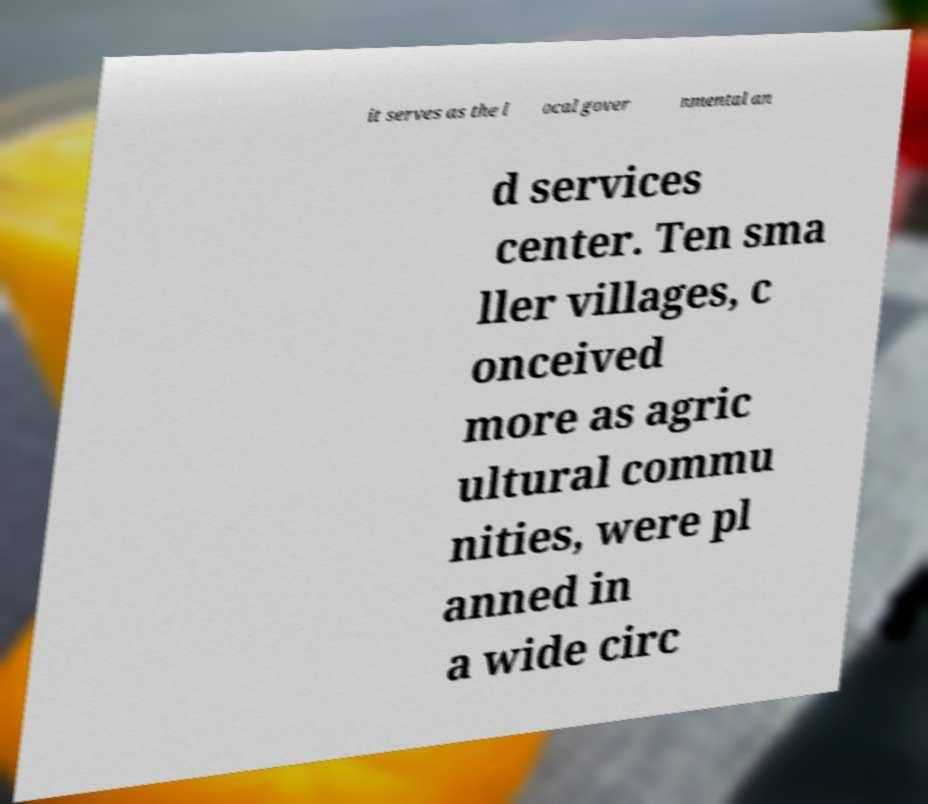Can you accurately transcribe the text from the provided image for me? it serves as the l ocal gover nmental an d services center. Ten sma ller villages, c onceived more as agric ultural commu nities, were pl anned in a wide circ 